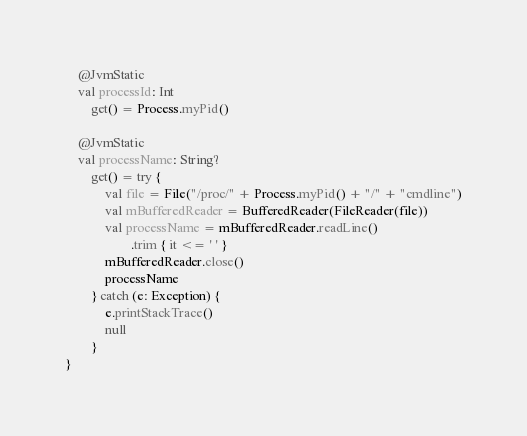Convert code to text. <code><loc_0><loc_0><loc_500><loc_500><_Kotlin_>
    @JvmStatic
    val processId: Int
        get() = Process.myPid()

    @JvmStatic
    val processName: String?
        get() = try {
            val file = File("/proc/" + Process.myPid() + "/" + "cmdline")
            val mBufferedReader = BufferedReader(FileReader(file))
            val processName = mBufferedReader.readLine()
                    .trim { it <= ' ' }
            mBufferedReader.close()
            processName
        } catch (e: Exception) {
            e.printStackTrace()
            null
        }
}</code> 